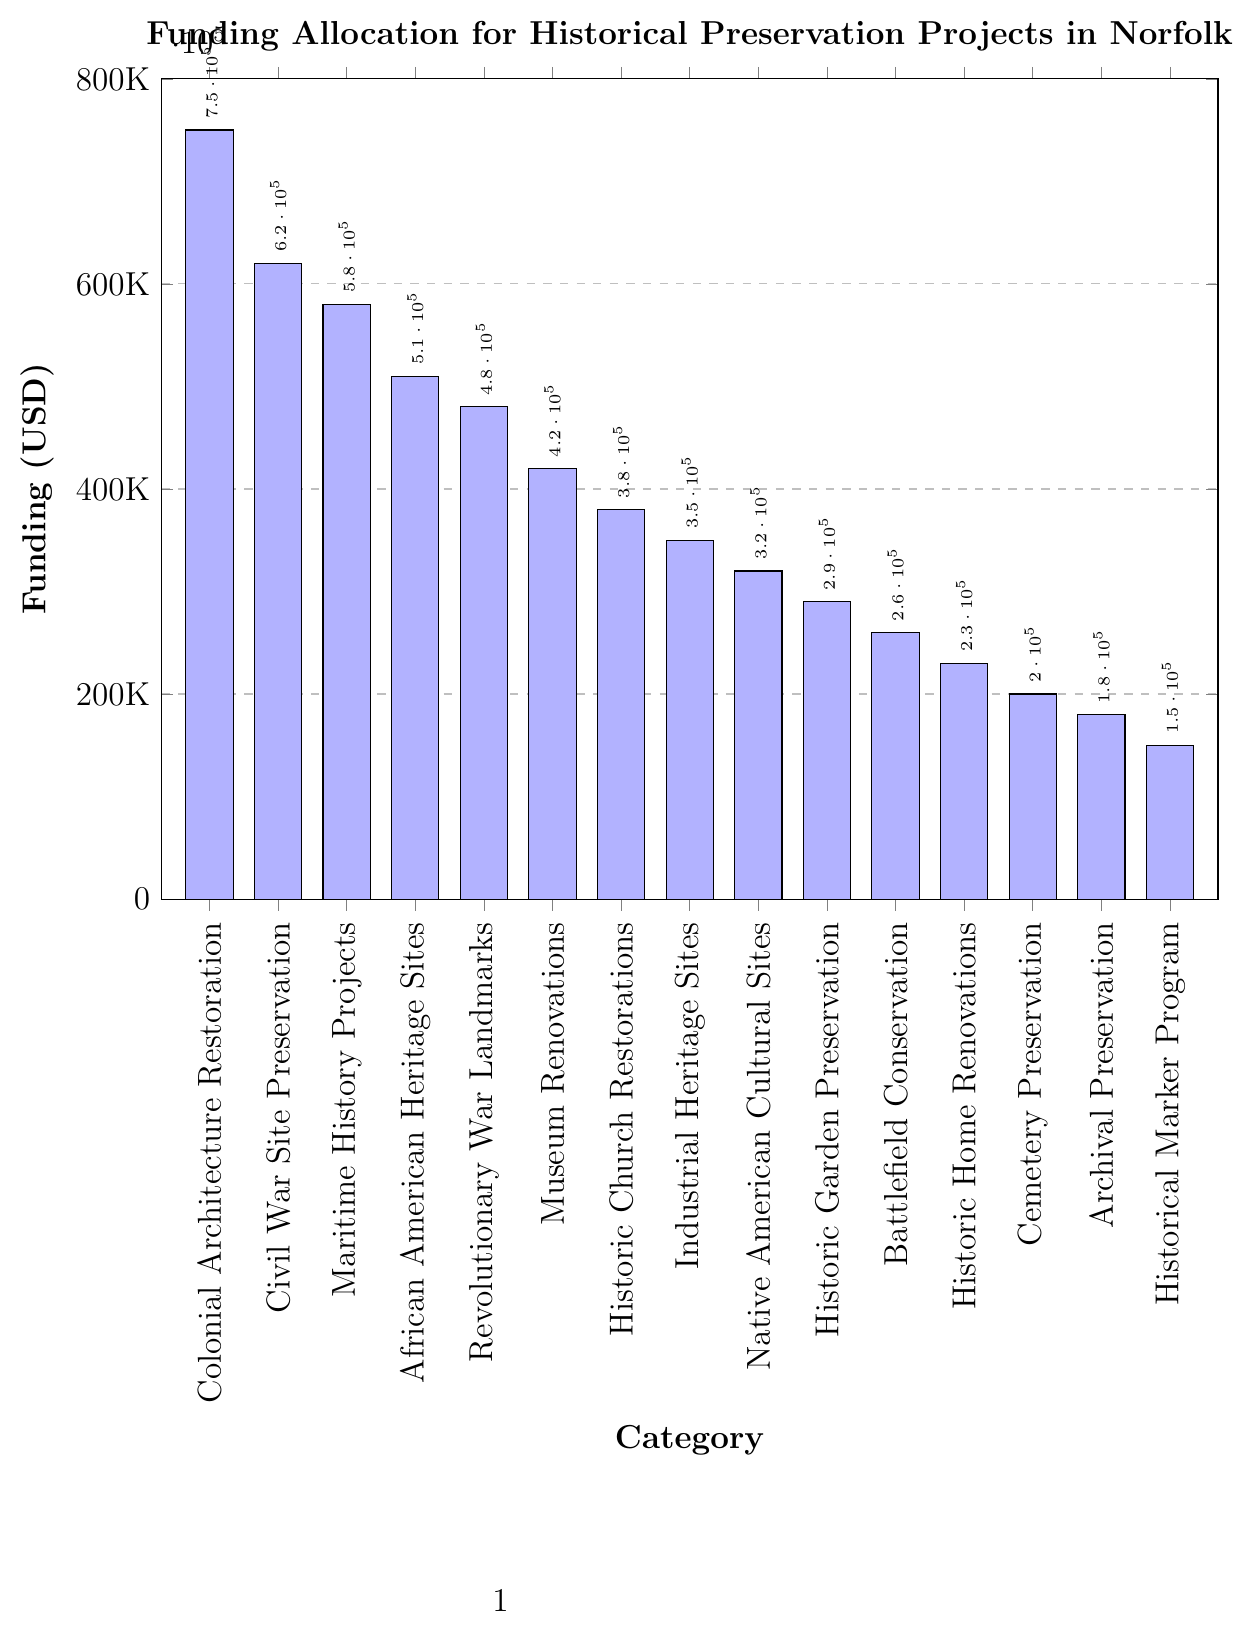Which category received the highest funding? The highest bar on the chart represents the category with the highest funding.
Answer: Colonial Architecture Restoration Which category received the lowest funding? The lowest bar on the chart represents the category with the lowest funding.
Answer: Historical Marker Program How much more funding did Colonial Architecture Restoration receive compared to the Historical Marker Program? Subtract the funding of the Historical Marker Program from the funding of Colonial Architecture Restoration: 750000 - 150000 = 600000.
Answer: 600000 What is the combined funding for African American Heritage Sites and Revolutionary War Landmarks? Add the funding for African American Heritage Sites and Revolutionary War Landmarks: 510000 + 480000 = 990000.
Answer: 990000 Which category received more funding: Maritime History Projects or Museum Renovations? Compare the two funding amounts: Maritime History Projects (580000) and Museum Renovations (420000).
Answer: Maritime History Projects What is the average funding of Colonial Architecture Restoration, Civil War Site Preservation, and Maritime History Projects? Add the funding amounts and divide by the number of categories: (750000 + 620000 + 580000) / 3 = 1950000 / 3 = 650000.
Answer: 650000 How does the funding for Historic Church Restorations compare to that of Industrial Heritage Sites? Compare the two funding amounts: Historic Church Restorations (380000) and Industrial Heritage Sites (350000).
Answer: Historic Church Restorations What is the difference in funding between the highest and lowest-funded categories? Subtract the funding of the lowest-funded category from the highest-funded category: 750000 - 150000 = 600000.
Answer: 600000 How much total funding was allocated to categories with funding less than 300,000 USD? Add the funding amounts for categories with less than 300,000 USD: Historic Garden Preservation (290000) + Battlefield Conservation (260000) + Historic Home Renovations (230000) + Cemetery Preservation (200000) + Archival Preservation (180000) + Historical Marker Program (150000) = 1310000.
Answer: 1310000 